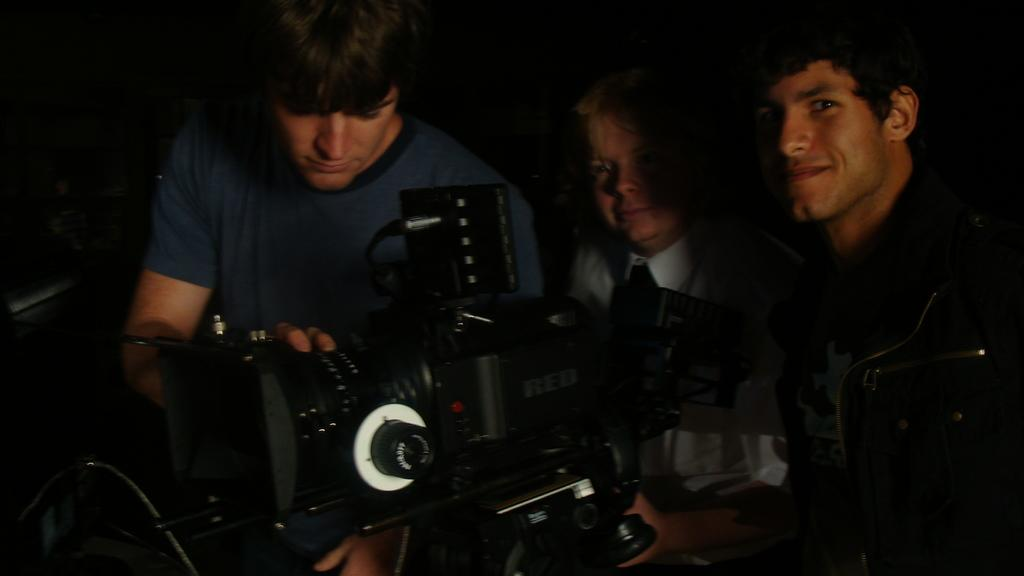How many men are in the image? There are three men in the image. What is the man on the left side of the image wearing? The man on the left side of the image is wearing a blue shirt. What is the man in the blue shirt holding? The man in the blue shirt is holding a video camera. How many sisters does the man in the blue shirt have in the image? There is no mention of sisters in the image, as it features three men and no women. 